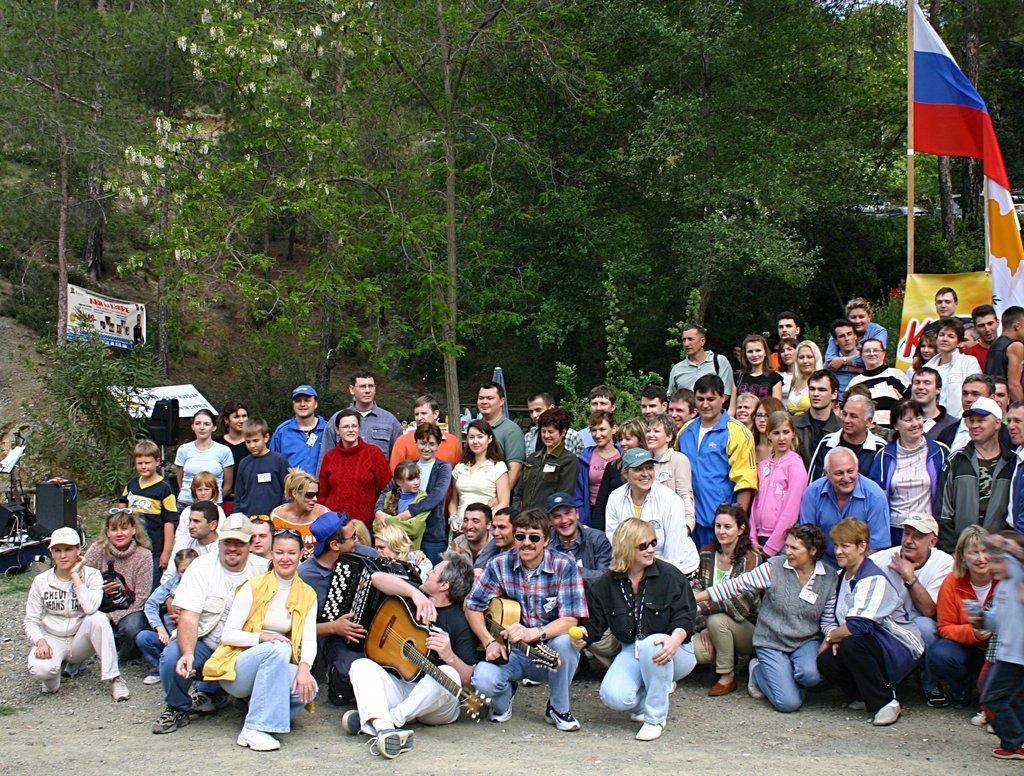How would you summarize this image in a sentence or two? Here we can see that a group of people sitting on the ground ,and some other are standing, and here the person is holding a guitar, and and at back the person is playing some musical drums, and at back there are trees, and here is the hoarding. 